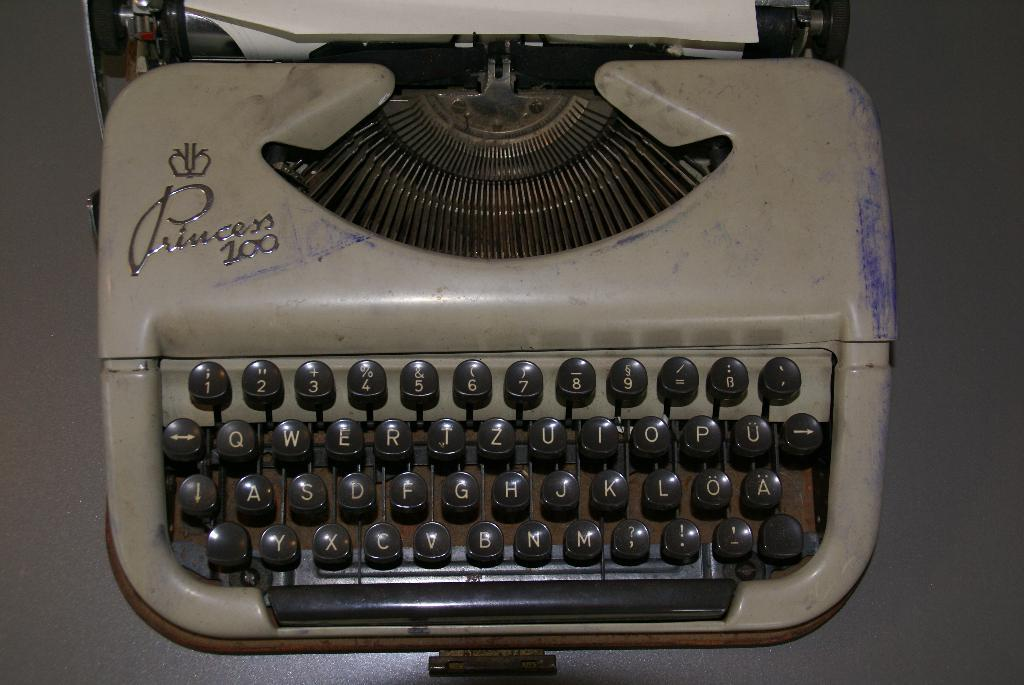What is the main object in the image? There is a typewriter in the image. What is placed on top of the typewriter? There is a paper at the top of the image. What surface is the typewriter placed on? There is a surface that looks like a table in the image. What type of comfort can be seen in the image? There is no indication of comfort in the image; it features a typewriter and paper on a table. How many tickets are visible in the image? There are no tickets present in the image. 